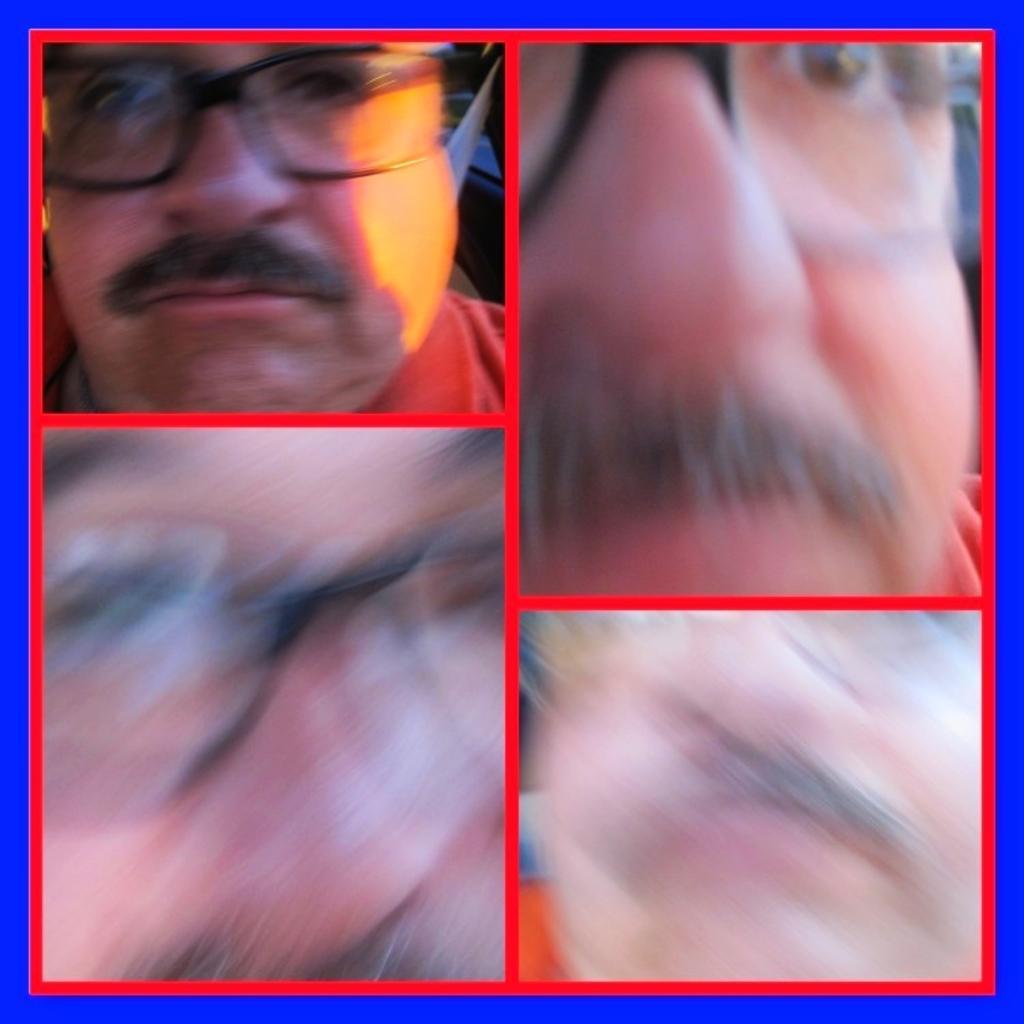Could you give a brief overview of what you see in this image? It is a collage image of a person's face. 